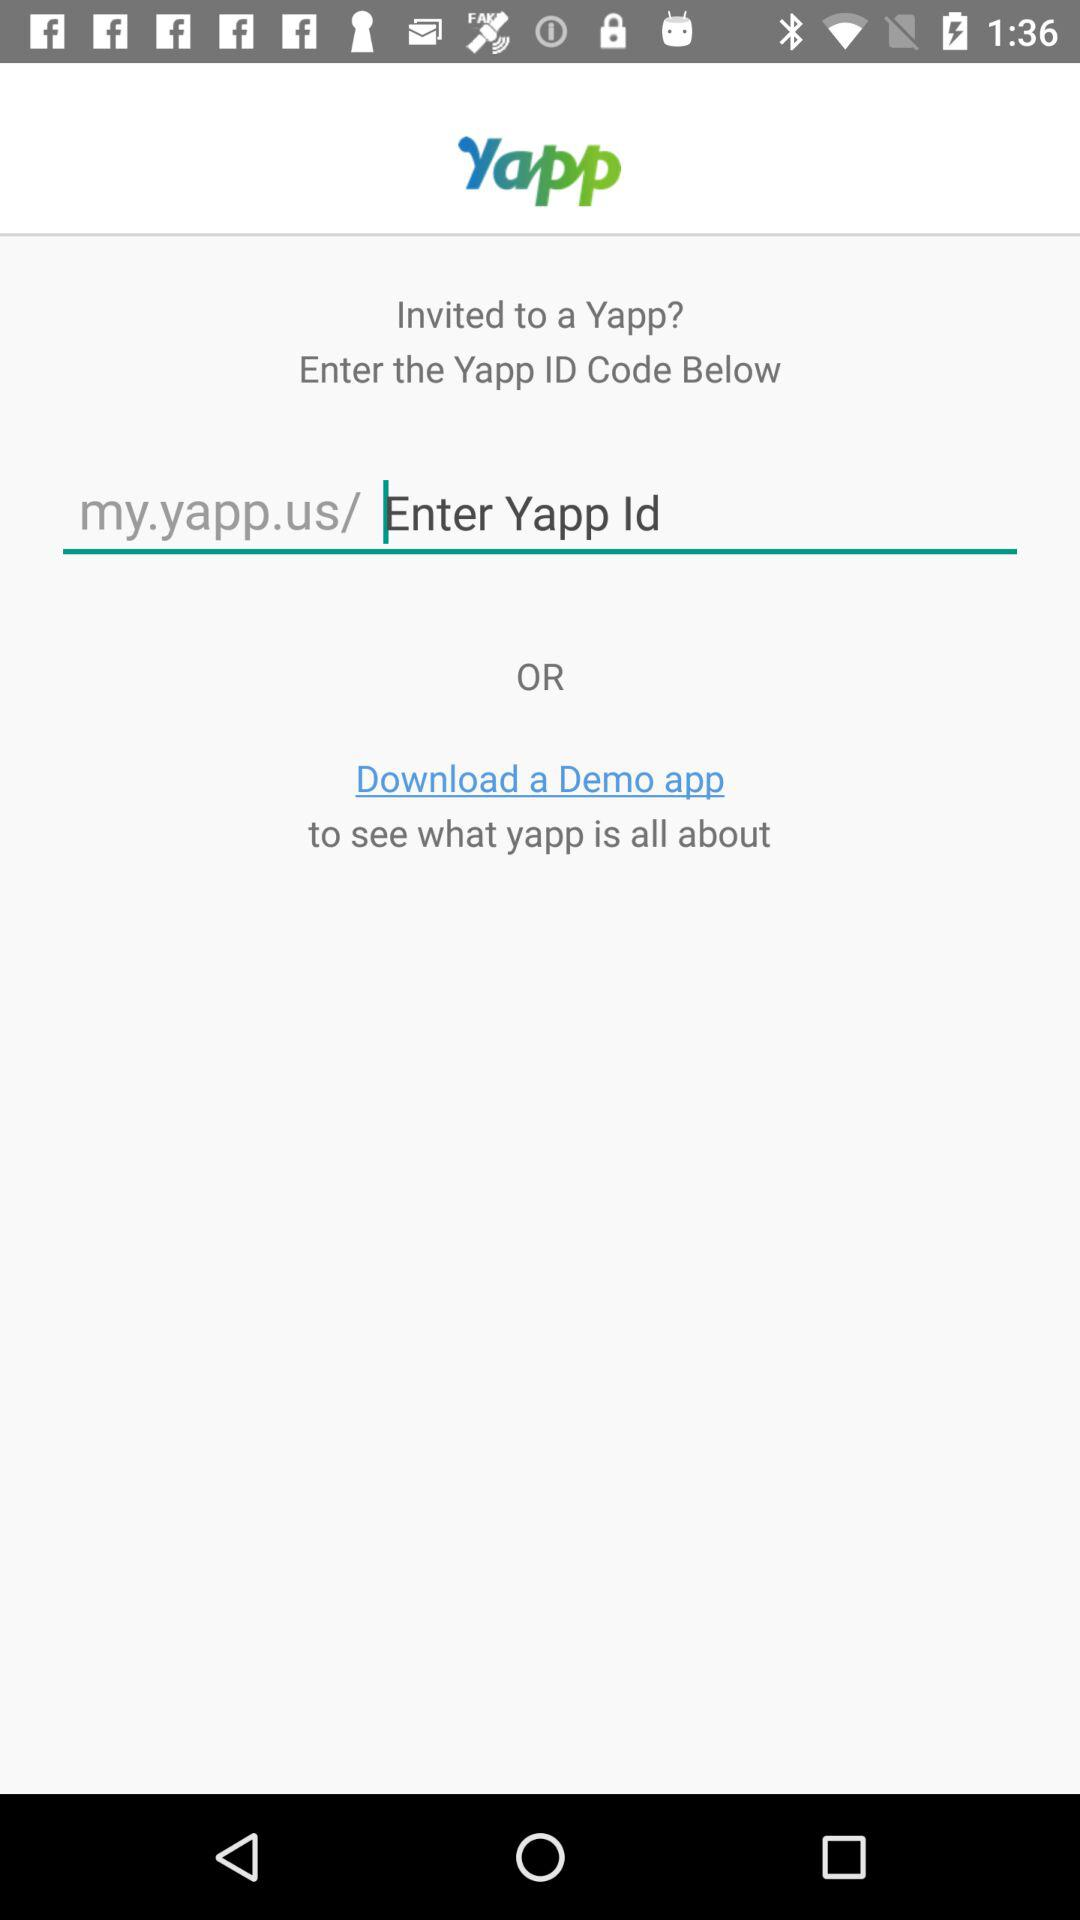What is the application name? The application name is "Yapp". 